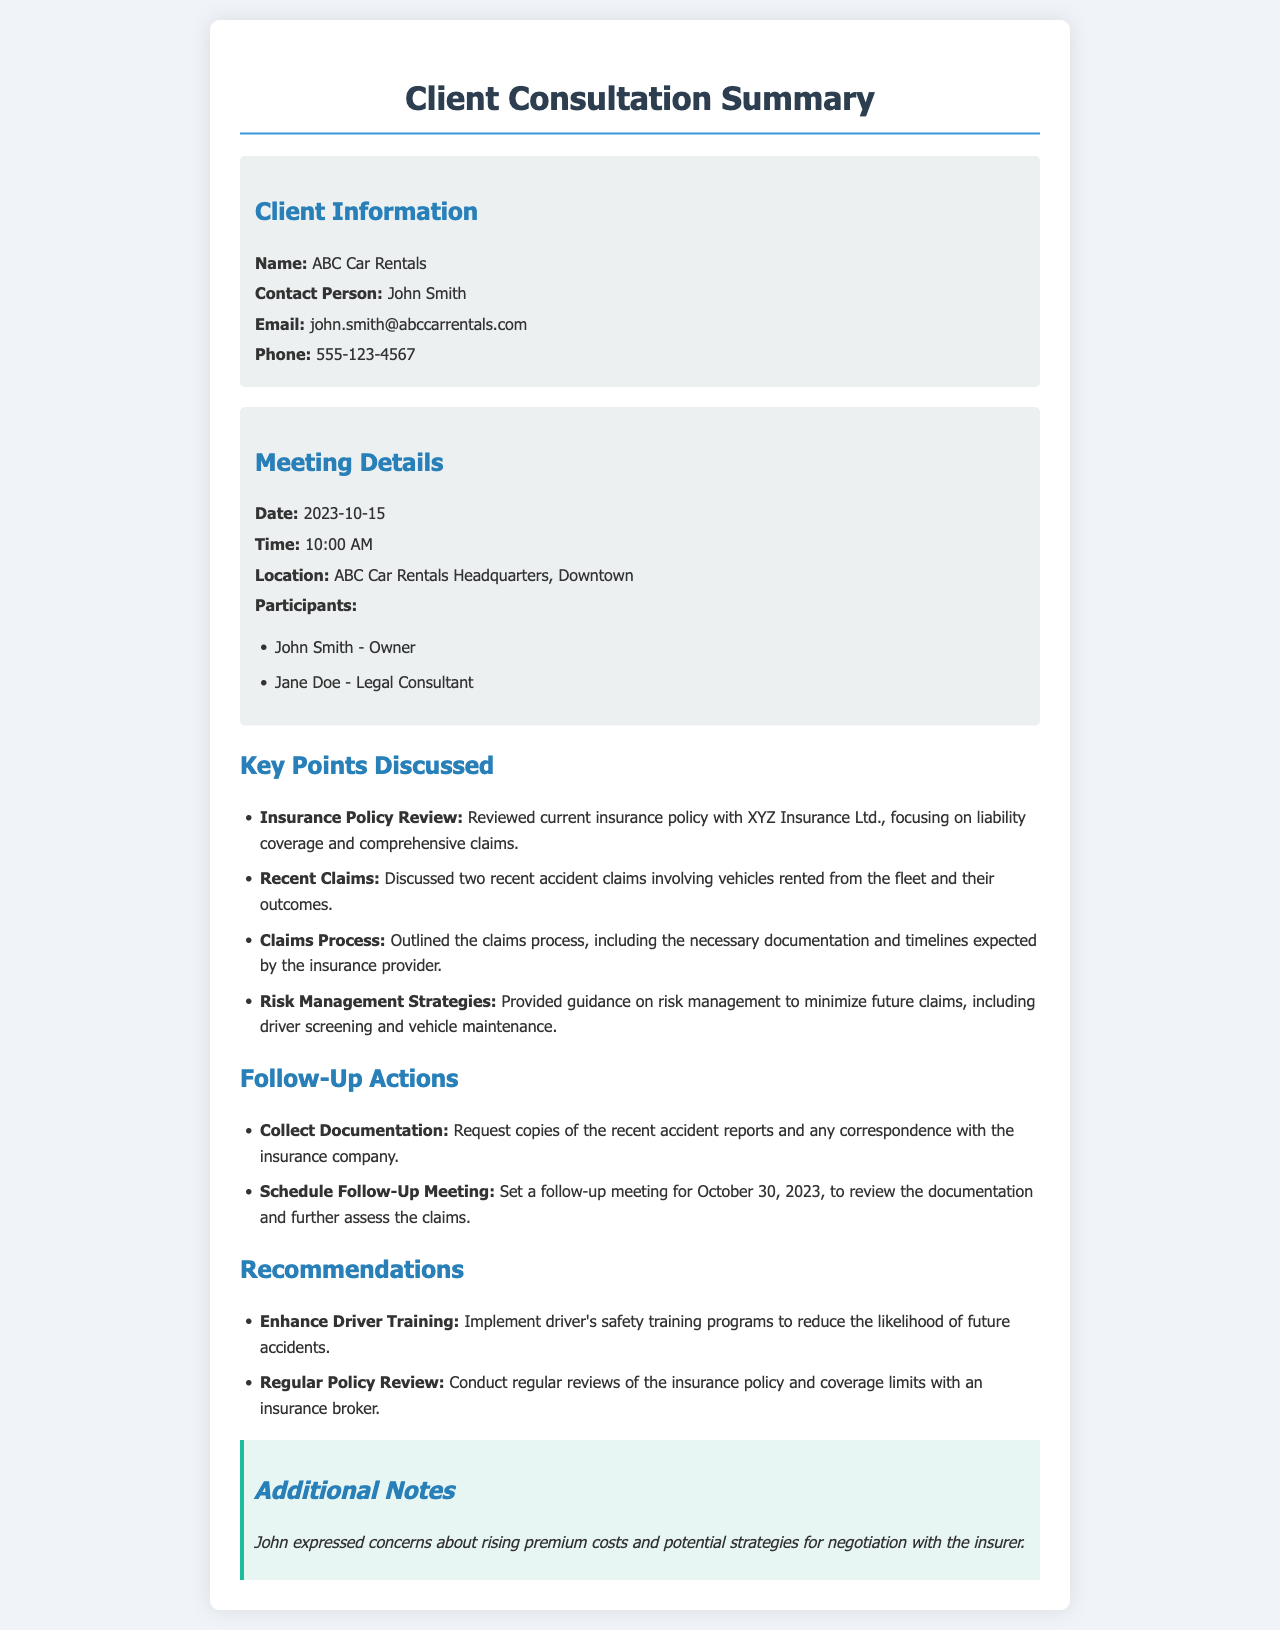what is the name of the car rental company? The name of the car rental company is provided in the client information section, which states "ABC Car Rentals."
Answer: ABC Car Rentals who is the contact person for ABC Car Rentals? The contact person's name is included in the client information section as "John Smith."
Answer: John Smith what is the email address of the contact person? The email address can be found in the client information section and is stated as "john.smith@abccarrentals.com."
Answer: john.smith@abccarrentals.com when was the meeting held? The meeting date is mentioned in the meeting details section as "2023-10-15."
Answer: 2023-10-15 how many accident claims were discussed during the meeting? The key points section mentions that "two recent accident claims" were discussed.
Answer: two what is one of the follow-up actions listed? The follow-up actions section outlines actions, one being "Request copies of the recent accident reports."
Answer: Request copies of the recent accident reports what is a recommendation made regarding driver training? The recommendations section includes the guideline "Implement driver's safety training programs."
Answer: Implement driver's safety training programs what concern did John express during the meeting? The additional notes section provides insight into concerns, specifically mentioning "rising premium costs."
Answer: rising premium costs what is the scheduled date for the follow-up meeting? The follow-up actions section states the follow-up meeting is set for "October 30, 2023."
Answer: October 30, 2023 